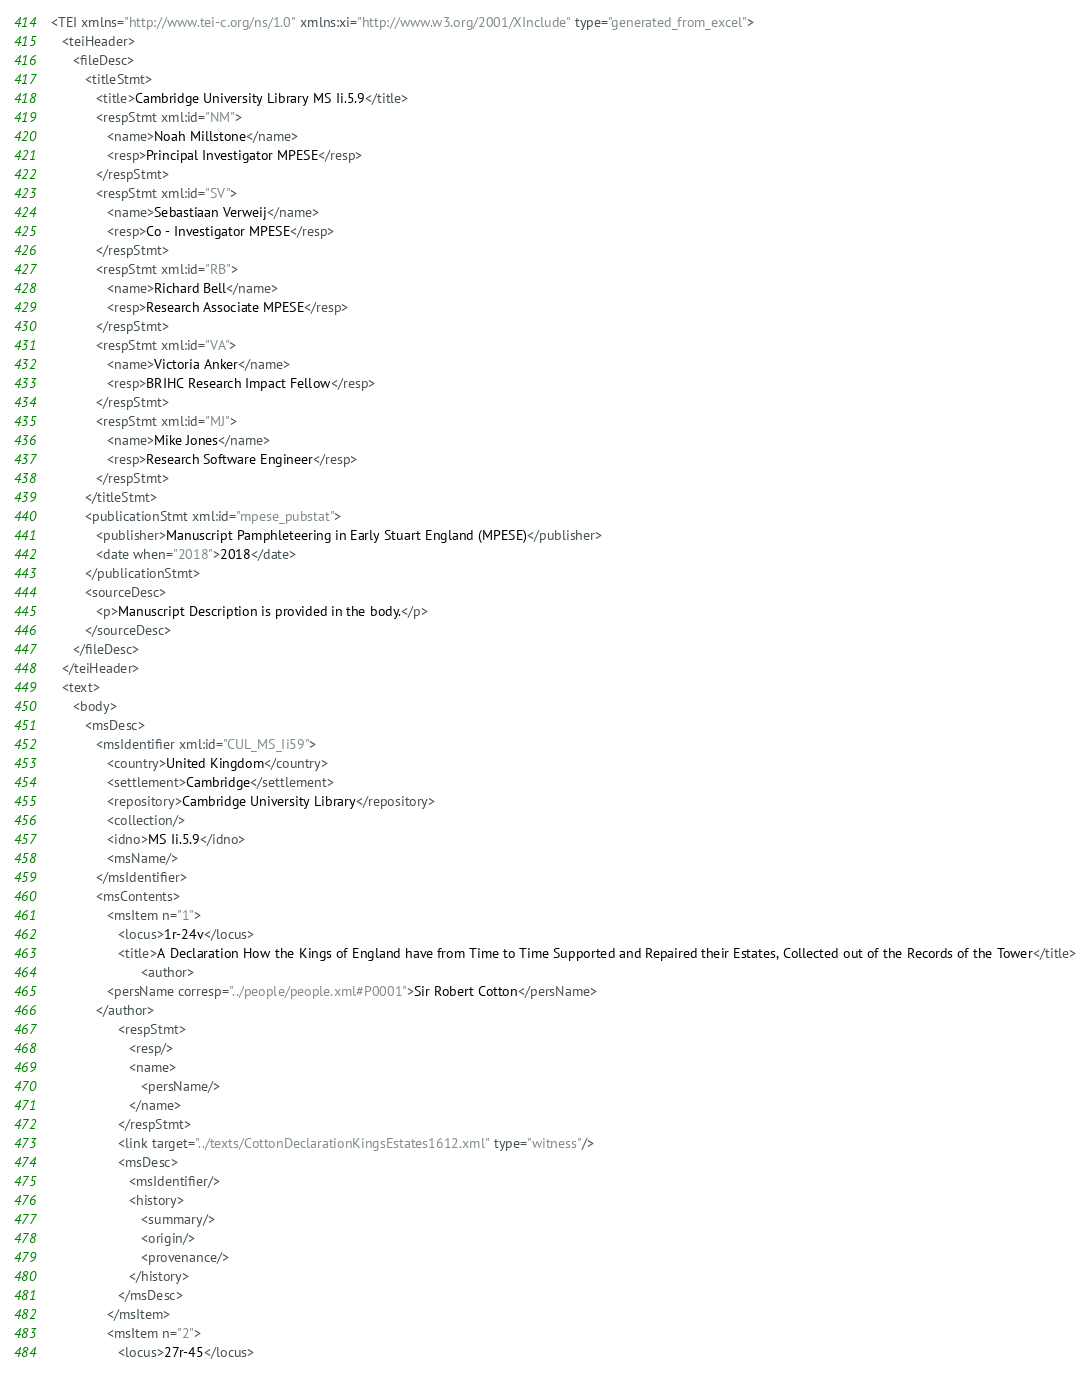<code> <loc_0><loc_0><loc_500><loc_500><_XML_><TEI xmlns="http://www.tei-c.org/ns/1.0" xmlns:xi="http://www.w3.org/2001/XInclude" type="generated_from_excel">
   <teiHeader>
      <fileDesc>
         <titleStmt>
            <title>Cambridge University Library MS Ii.5.9</title>
            <respStmt xml:id="NM">
               <name>Noah Millstone</name>
               <resp>Principal Investigator MPESE</resp>
            </respStmt>
            <respStmt xml:id="SV">
               <name>Sebastiaan Verweij</name>
               <resp>Co - Investigator MPESE</resp>
            </respStmt>
            <respStmt xml:id="RB">
               <name>Richard Bell</name>
               <resp>Research Associate MPESE</resp>
            </respStmt>
            <respStmt xml:id="VA">
               <name>Victoria Anker</name>
               <resp>BRIHC Research Impact Fellow</resp>
            </respStmt>
            <respStmt xml:id="MJ">
               <name>Mike Jones</name>
               <resp>Research Software Engineer</resp>
            </respStmt>
         </titleStmt>
         <publicationStmt xml:id="mpese_pubstat">
            <publisher>Manuscript Pamphleteering in Early Stuart England (MPESE)</publisher>
            <date when="2018">2018</date>
         </publicationStmt>
         <sourceDesc>
            <p>Manuscript Description is provided in the body.</p>
         </sourceDesc>
      </fileDesc>
   </teiHeader>
   <text>
      <body>
         <msDesc>
            <msIdentifier xml:id="CUL_MS_Ii59">
               <country>United Kingdom</country>
               <settlement>Cambridge</settlement>
               <repository>Cambridge University Library</repository>
               <collection/>
               <idno>MS Ii.5.9</idno>
               <msName/>
            </msIdentifier>
            <msContents>
               <msItem n="1">
                  <locus>1r-24v</locus>
                  <title>A Declaration How the Kings of England have from Time to Time Supported and Repaired their Estates, Collected out of the Records of the Tower</title>
                        <author>
               <persName corresp="../people/people.xml#P0001">Sir Robert Cotton</persName>
            </author>
                  <respStmt>
                     <resp/>
                     <name>
                        <persName/>
                     </name>
                  </respStmt>
                  <link target="../texts/CottonDeclarationKingsEstates1612.xml" type="witness"/>
                  <msDesc>
                     <msIdentifier/>
                     <history>
                        <summary/>
                        <origin/>
                        <provenance/>
                     </history>
                  </msDesc>
               </msItem>
               <msItem n="2">
                  <locus>27r-45</locus></code> 